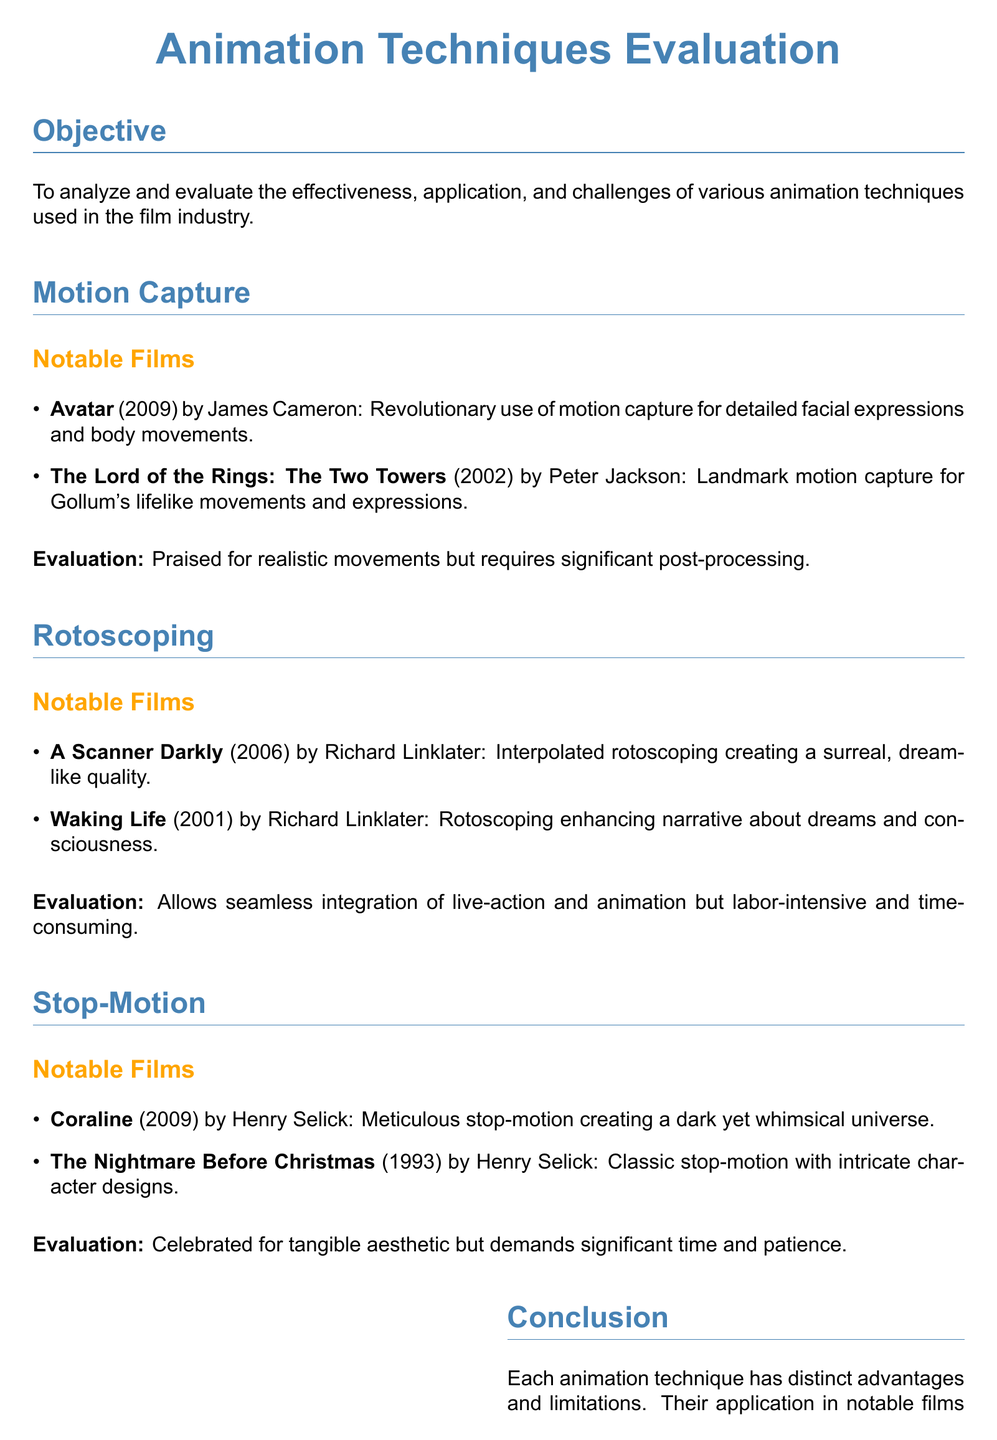What film is known for its revolutionary use of motion capture? The document states that "Avatar" (2009) is known for its revolutionary use of motion capture.
Answer: Avatar (2009) Which notable film used rotoscoping to enhance a narrative about dreams? The document mentions "Waking Life" (2001) as a film that used rotoscoping to enhance its narrative about dreams and consciousness.
Answer: Waking Life (2001) What technique involves creating a tangible aesthetic but demands significant time and patience? The document discusses stop-motion as a technique that is celebrated for its tangible aesthetic but requires significant time and patience.
Answer: Stop-motion Name a film that showcased landmark motion capture for character movements. According to the document, "The Lord of the Rings: The Two Towers" (2002) showcased landmark motion capture for Gollum's lifelike movements and expressions.
Answer: The Lord of the Rings: The Two Towers (2002) What is one challenge associated with using rotoscoping in animation? The document states that while rotoscoping allows seamless integration, it is labor-intensive and time-consuming.
Answer: Labor-intensive and time-consuming Which animation technique is associated with a dark yet whimsical universe in a film by Henry Selick? The document indicates that "Coraline" (2009) by Henry Selick uses meticulous stop-motion to create a dark yet whimsical universe.
Answer: Coraline (2009) Who directed "A Scanner Darkly"? The document attributes "A Scanner Darkly" (2006) to director Richard Linklater.
Answer: Richard Linklater What is the main objective of the document? The document outlines that the objective is to analyze and evaluate the effectiveness, application, and challenges of various animation techniques used in the film industry.
Answer: Analyze and evaluate animation techniques Which section of the document emphasizes opportunities for aspiring animators? The document includes a section titled "For the Aspiring Animator" that emphasizes opportunities and skill enhancement for aspiring animators.
Answer: For the Aspiring Animator 